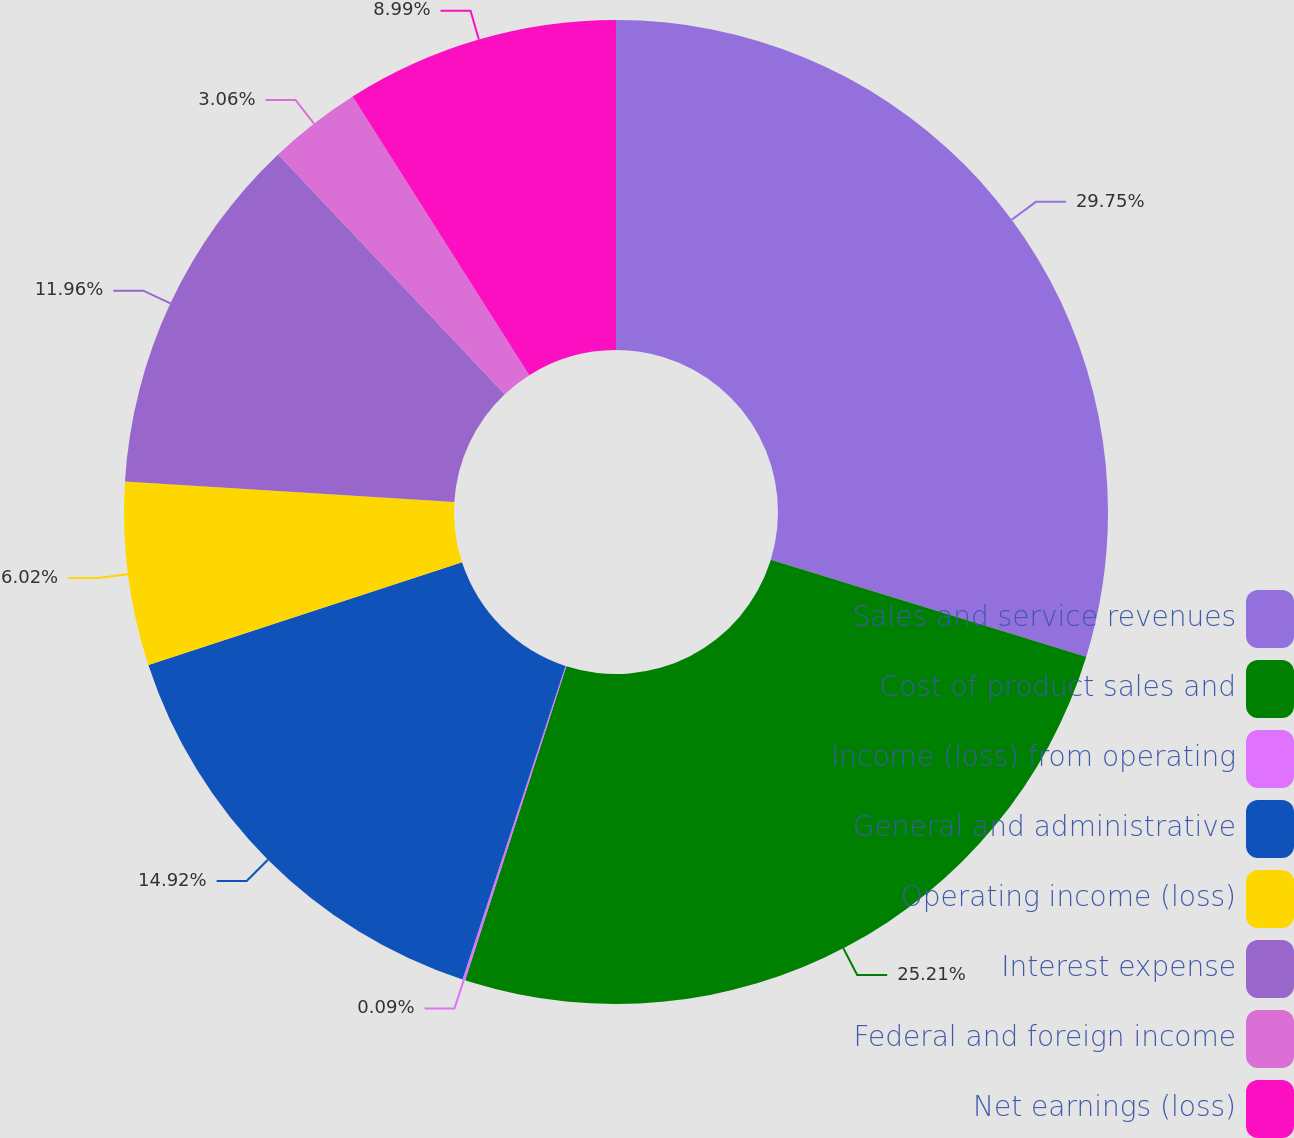<chart> <loc_0><loc_0><loc_500><loc_500><pie_chart><fcel>Sales and service revenues<fcel>Cost of product sales and<fcel>Income (loss) from operating<fcel>General and administrative<fcel>Operating income (loss)<fcel>Interest expense<fcel>Federal and foreign income<fcel>Net earnings (loss)<nl><fcel>29.75%<fcel>25.21%<fcel>0.09%<fcel>14.92%<fcel>6.02%<fcel>11.96%<fcel>3.06%<fcel>8.99%<nl></chart> 